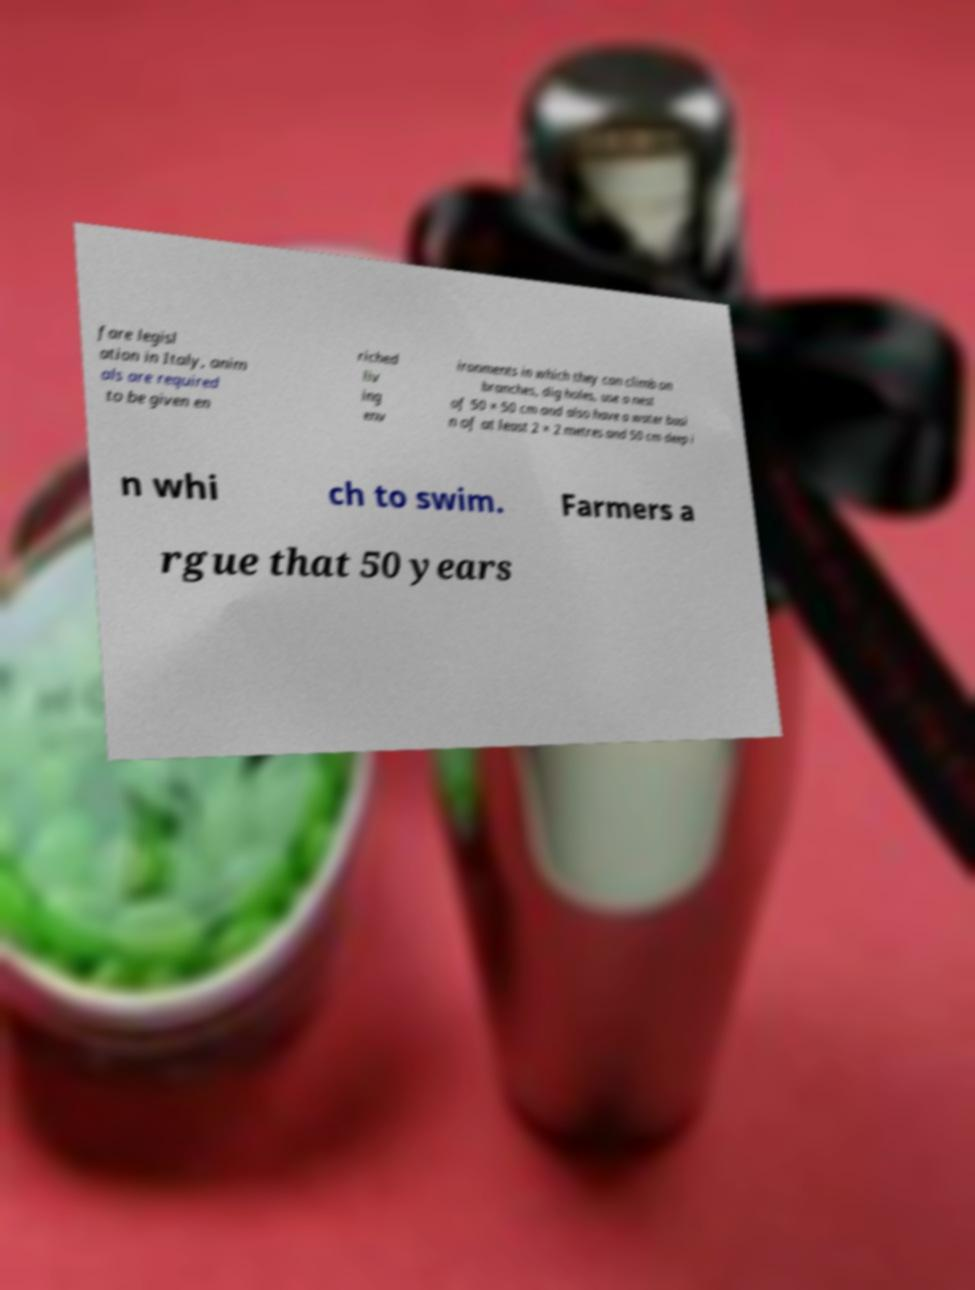Could you extract and type out the text from this image? fare legisl ation in Italy, anim als are required to be given en riched liv ing env ironments in which they can climb on branches, dig holes, use a nest of 50 × 50 cm and also have a water basi n of at least 2 × 2 metres and 50 cm deep i n whi ch to swim. Farmers a rgue that 50 years 